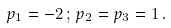<formula> <loc_0><loc_0><loc_500><loc_500>p _ { 1 } = - 2 \, ; \, p _ { 2 } = p _ { 3 } = 1 \, .</formula> 